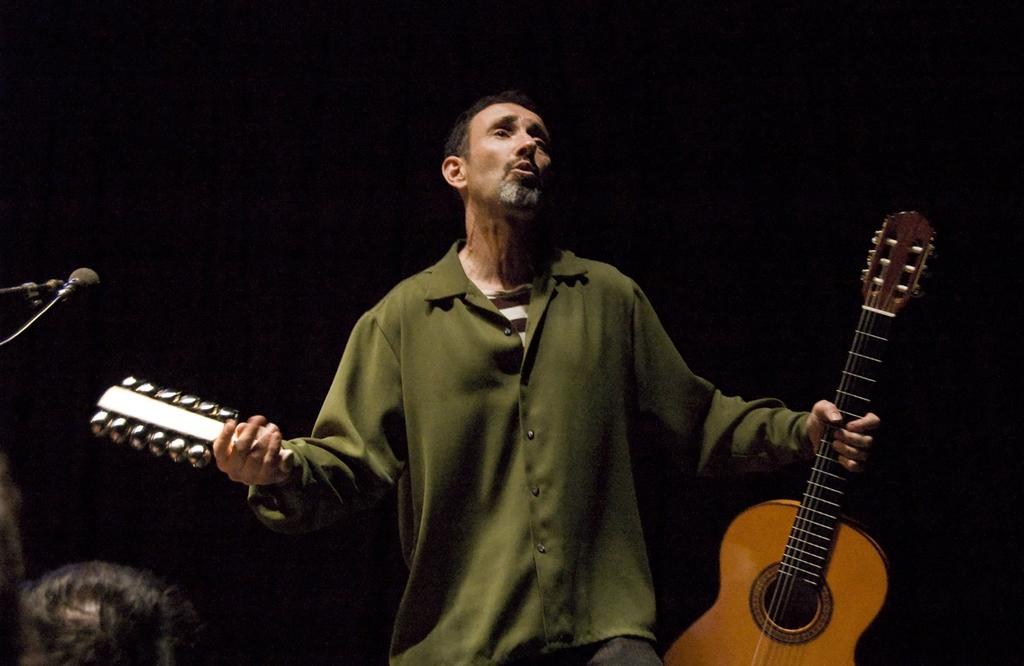What is the main subject of the image? The main subject of the image is a man. What is the man doing in the image? The man is standing in the image. What object is the man holding in his hand? The man is holding a guitar in his hand. What other musical instrument can be seen in the image? There is another musical instrument in the image. What device is present for amplifying sound in the image? There is a microphone with a stand in the image. What type of balls can be seen rolling on the floor in the image? There are no balls visible in the image. What kind of dirt can be seen on the man's shoes in the image? There is no dirt visible on the man's shoes in the image. 